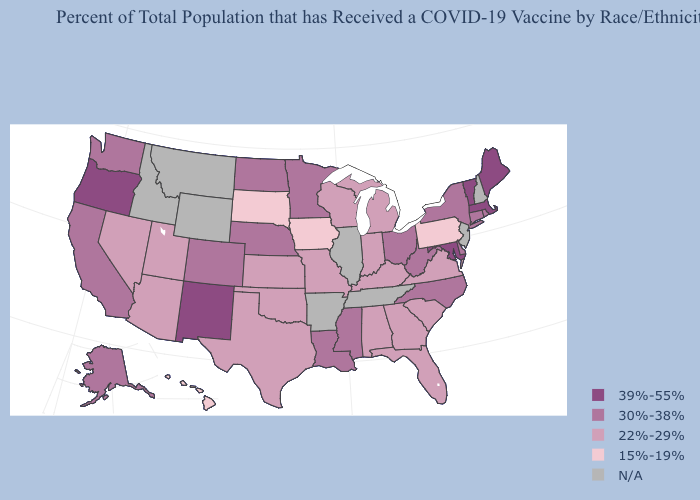Does Oregon have the highest value in the USA?
Keep it brief. Yes. Name the states that have a value in the range 30%-38%?
Write a very short answer. Alaska, California, Colorado, Connecticut, Delaware, Louisiana, Minnesota, Mississippi, Nebraska, New York, North Carolina, North Dakota, Ohio, Rhode Island, Washington, West Virginia. What is the highest value in the MidWest ?
Keep it brief. 30%-38%. Name the states that have a value in the range 30%-38%?
Answer briefly. Alaska, California, Colorado, Connecticut, Delaware, Louisiana, Minnesota, Mississippi, Nebraska, New York, North Carolina, North Dakota, Ohio, Rhode Island, Washington, West Virginia. What is the lowest value in the USA?
Answer briefly. 15%-19%. What is the lowest value in the Northeast?
Give a very brief answer. 15%-19%. Does North Dakota have the highest value in the USA?
Write a very short answer. No. What is the lowest value in the South?
Be succinct. 22%-29%. Is the legend a continuous bar?
Answer briefly. No. Name the states that have a value in the range N/A?
Answer briefly. Arkansas, Idaho, Illinois, Montana, New Hampshire, New Jersey, Tennessee, Wyoming. Name the states that have a value in the range 15%-19%?
Keep it brief. Hawaii, Iowa, Pennsylvania, South Dakota. What is the value of Arkansas?
Give a very brief answer. N/A. 